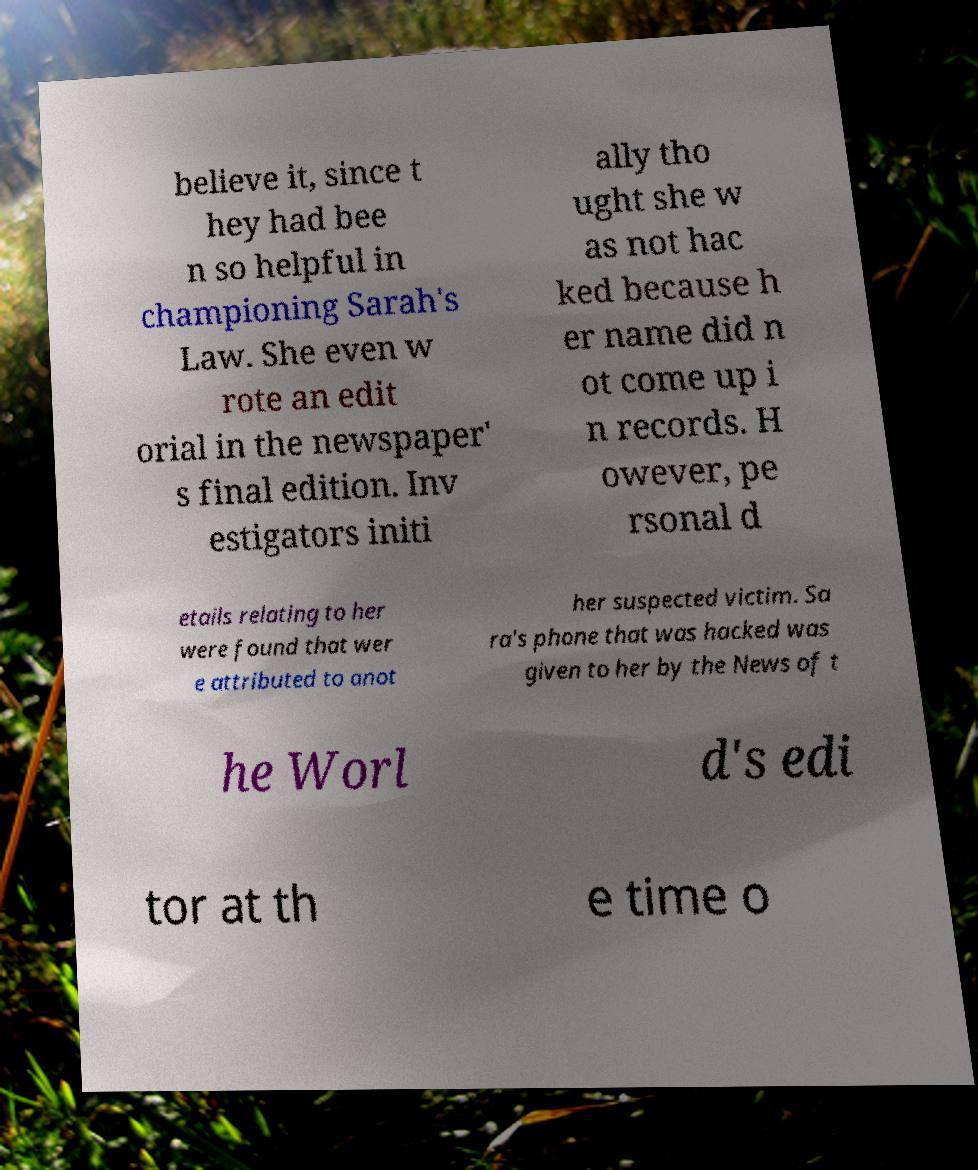Can you accurately transcribe the text from the provided image for me? believe it, since t hey had bee n so helpful in championing Sarah's Law. She even w rote an edit orial in the newspaper' s final edition. Inv estigators initi ally tho ught she w as not hac ked because h er name did n ot come up i n records. H owever, pe rsonal d etails relating to her were found that wer e attributed to anot her suspected victim. Sa ra's phone that was hacked was given to her by the News of t he Worl d's edi tor at th e time o 